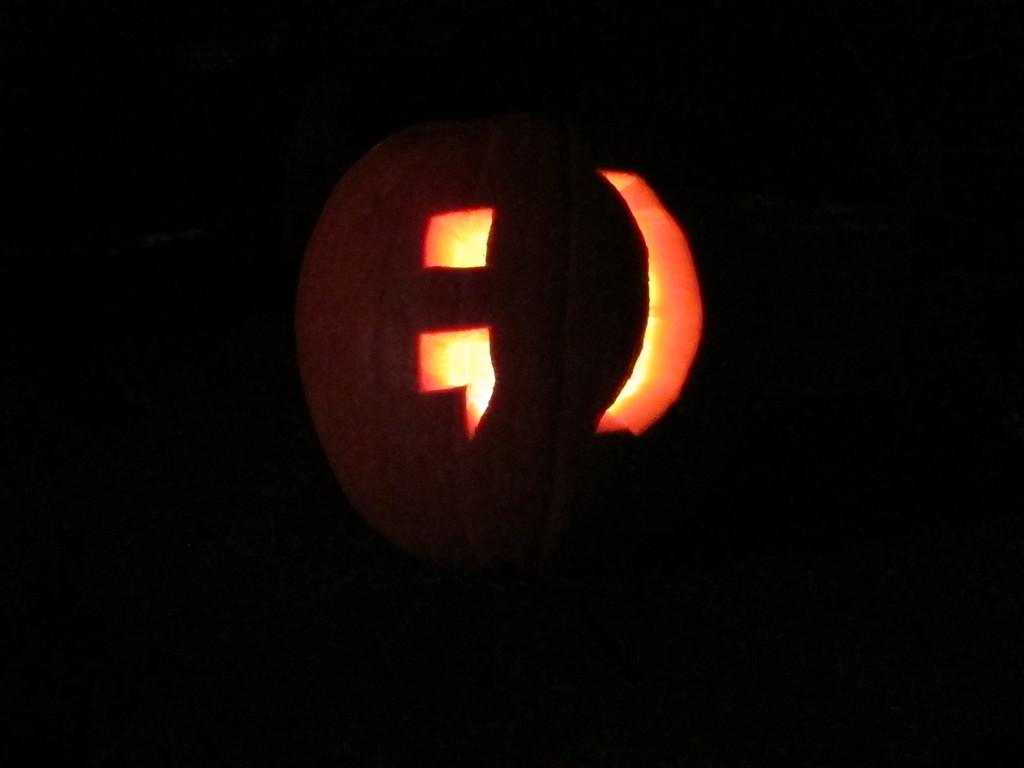What is the main subject of the image? The main subject of the image is a pumpkin. How is the pumpkin depicted in the image? The pumpkin is truncated in the image. What can be observed about the overall appearance of the image? The background of the image is dark. How many bikes are parked next to the pumpkin in the image? There are no bikes present in the image; it only features a pumpkin. What type of engine is visible in the pumpkin image? There is no engine visible in the image; it only features a pumpkin. 